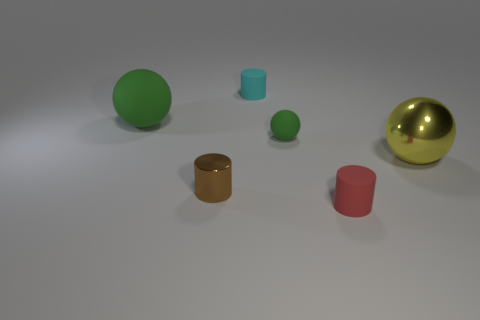Subtract all small brown metallic cylinders. How many cylinders are left? 2 Subtract all brown cylinders. How many green spheres are left? 2 Add 1 green rubber spheres. How many objects exist? 7 Subtract all gray balls. Subtract all gray cubes. How many balls are left? 3 Subtract all large gray matte balls. Subtract all big green matte objects. How many objects are left? 5 Add 3 small green objects. How many small green objects are left? 4 Add 1 blue matte objects. How many blue matte objects exist? 1 Subtract 0 yellow cylinders. How many objects are left? 6 